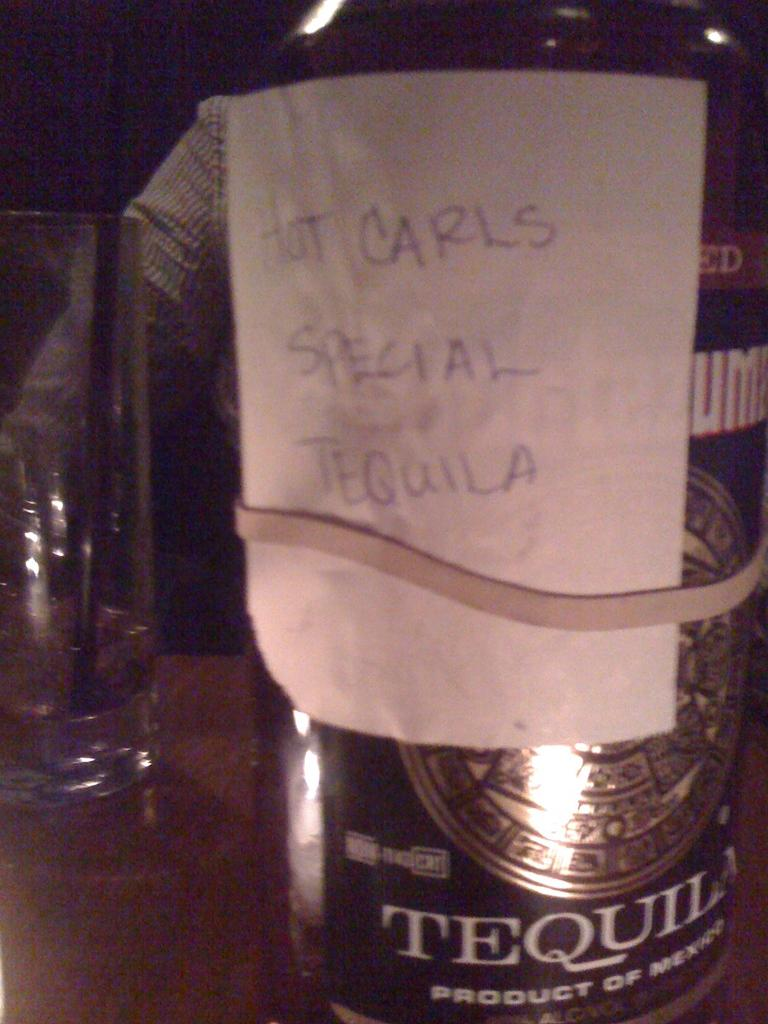Provide a one-sentence caption for the provided image. A bottle with a written note designating it Hot Carls Special Tequila is held on with a rubber band. 